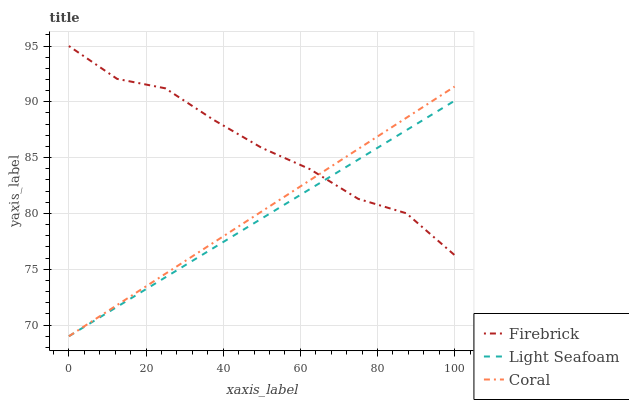Does Light Seafoam have the minimum area under the curve?
Answer yes or no. Yes. Does Firebrick have the maximum area under the curve?
Answer yes or no. Yes. Does Coral have the minimum area under the curve?
Answer yes or no. No. Does Coral have the maximum area under the curve?
Answer yes or no. No. Is Light Seafoam the smoothest?
Answer yes or no. Yes. Is Firebrick the roughest?
Answer yes or no. Yes. Is Coral the smoothest?
Answer yes or no. No. Is Coral the roughest?
Answer yes or no. No. Does Light Seafoam have the lowest value?
Answer yes or no. Yes. Does Firebrick have the highest value?
Answer yes or no. Yes. Does Coral have the highest value?
Answer yes or no. No. Does Coral intersect Light Seafoam?
Answer yes or no. Yes. Is Coral less than Light Seafoam?
Answer yes or no. No. Is Coral greater than Light Seafoam?
Answer yes or no. No. 